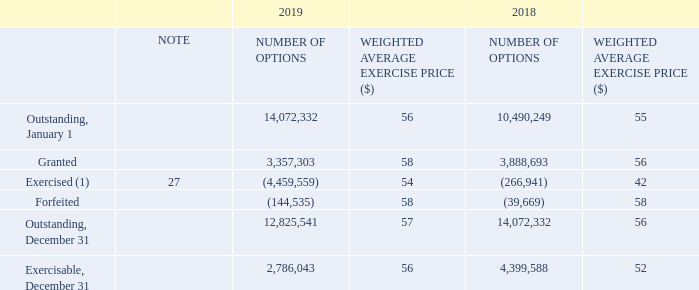STOCK OPTIONS
Under BCE’s long-term incentive plans, BCE may grant options to executives to buy BCE common shares. The subscription price of a grant is based on the higher of: • the volume-weighted average of the trading price on the trading day immediately prior to the effective date of the grant • the volume-weighted average of the trading price for the last five consecutive trading days ending on the trading day immediately prior to the effective date of the grant
At December 31, 2019, 7,524,891 common shares were authorized for issuance under these plans. Options vest fully after three years of continuous employment from the date of grant. All options become exercisable when they vest and can be exercised for a period of seven years from the date of grant for options granted prior to 2019 and ten years from the date of grant for options granted in 2019.
The following table summarizes BCE’s outstanding stock options at December 31, 2019 and 2018.
(1) The weighted average market share price for options exercised was $62 in 2019 and $55 in 2018.
Who can BCE grant options to under BCE's long-term incentive plans? Executives to buy bce common shares. How many common shares were authorized for issuance in 2019? 7,524,891. Which years have the weighted average market share price for options exercised provided? 2019, 2018. Which year is the weighted average market share price for options exercised higher? $62>$55
Answer: 2019. What is the change in granted options in 2019? 3,357,303-3,888,693
Answer: -531390. What is the percentage change in the exercisable number of options in December 31, 2019?
Answer scale should be: percent. (2,786,043-4,399,588)/4,399,588
Answer: -36.67. 